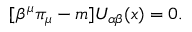Convert formula to latex. <formula><loc_0><loc_0><loc_500><loc_500>[ \beta ^ { \mu } \pi _ { \mu } - m ] U _ { \alpha \beta } ( x ) = 0 .</formula> 